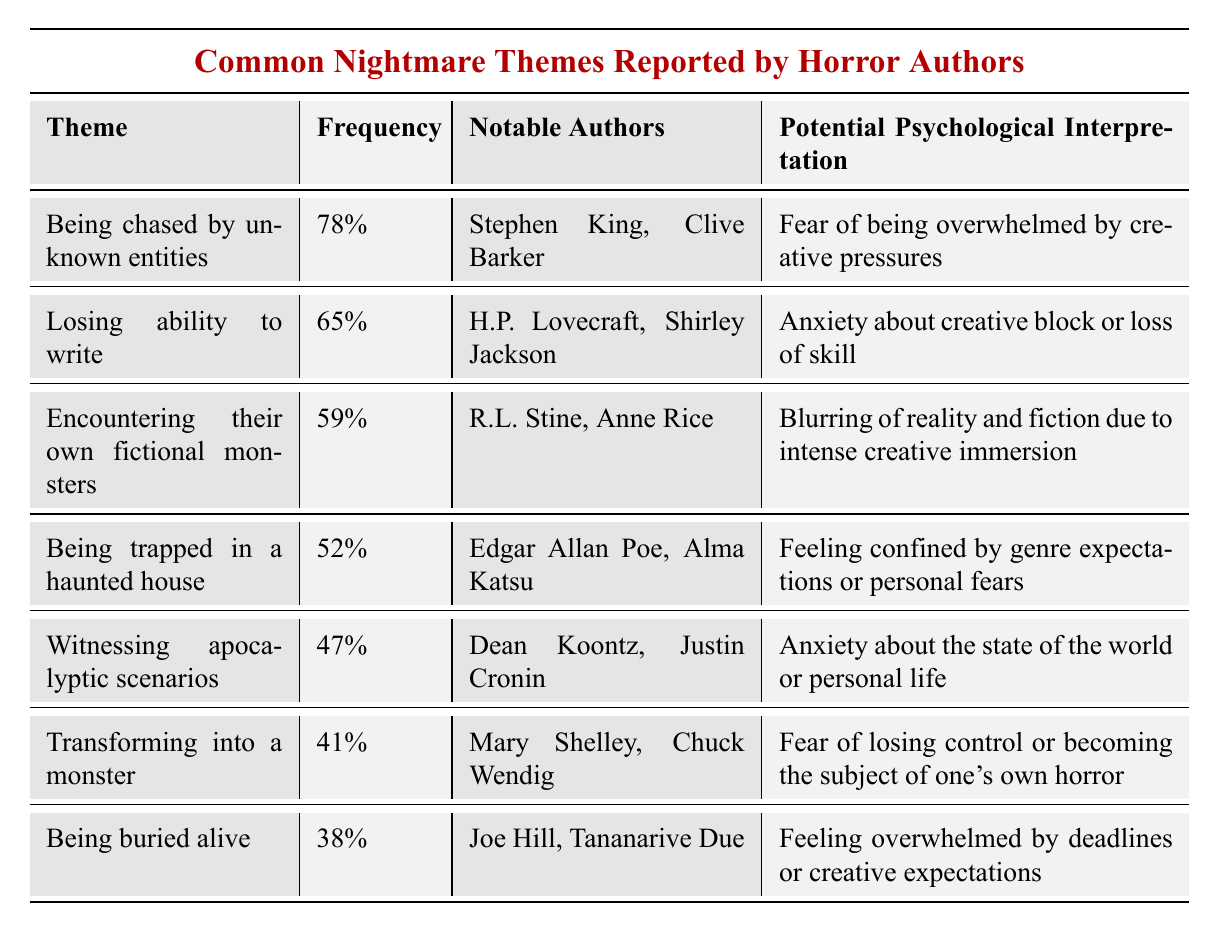What is the most common nightmare theme reported by horror authors? The table indicates that "Being chased by unknown entities" is the most common theme, with a frequency of 78%.
Answer: Being chased by unknown entities Which authors reported experiencing the nightmare of losing the ability to write? According to the table, H.P. Lovecraft and Shirley Jackson are the notable authors who reported this nightmare theme.
Answer: H.P. Lovecraft, Shirley Jackson What percentage of authors experience nightmares about being trapped in a haunted house? The table states that 52% of authors report nightmares about being trapped in a haunted house.
Answer: 52% Is witnessing apocalyptic scenarios more common than transforming into a monster? Yes, the table shows that 47% report witnessing apocalyptic scenarios, while only 41% report transforming into a monster, meaning witnessing apocalyptic scenarios is indeed more common.
Answer: Yes How many nightmare themes have a frequency of 50% or more? The table lists four themes with frequencies equal to or exceeding 50%: Being chased by unknown entities, losing ability to write, encountering own fictional monsters, and being trapped in a haunted house.
Answer: 4 What is the frequency difference between the themes of being buried alive and witnessing apocalyptic scenarios? The frequency for being buried alive is 38% and for witnessing apocalyptic scenarios is 47%. The difference is calculated as 47% - 38% = 9%.
Answer: 9% Which notable authors have encountered their own fictional monsters? The table reports that R.L. Stine and Anne Rice have encountered their own fictional monsters in nightmares.
Answer: R.L. Stine, Anne Rice Is the psychological interpretation for being buried alive related to creative expectations? Yes, the table explains that the potential psychological interpretation for being buried alive is related to feeling overwhelmed by deadlines or creative expectations.
Answer: Yes If we average the frequencies of the nightmare themes listed, what would be the result? To find the average, sum the frequencies (78 + 65 + 59 + 52 + 47 + 41 + 38) = 380 and divide by the number of themes (7), resulting in 380/7 = 54.29 (approximately).
Answer: 54.29 What percentage of authors report transforming into a monster compared to those reporting being buried alive? The table indicates that 41% report transforming into a monster and 38% report being buried alive. The comparison shows that 41% is greater than 38%.
Answer: 41% vs 38% (41% is greater) 